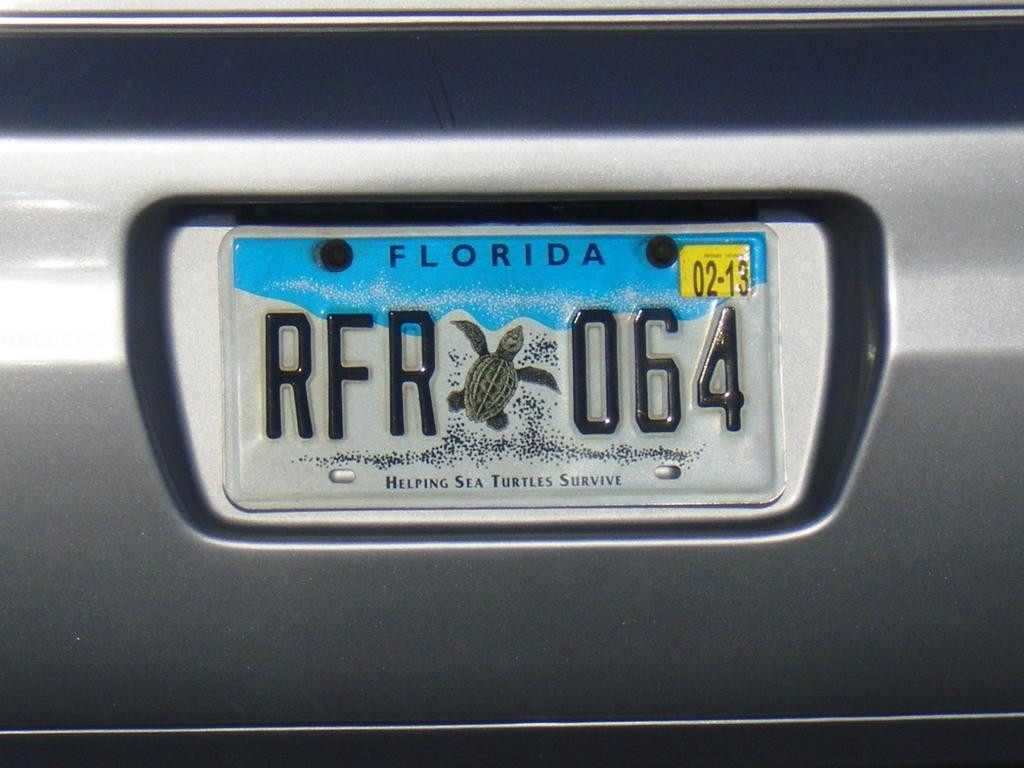<image>
Offer a succinct explanation of the picture presented. A Florida sea turtle tag that reads RFR 064. 